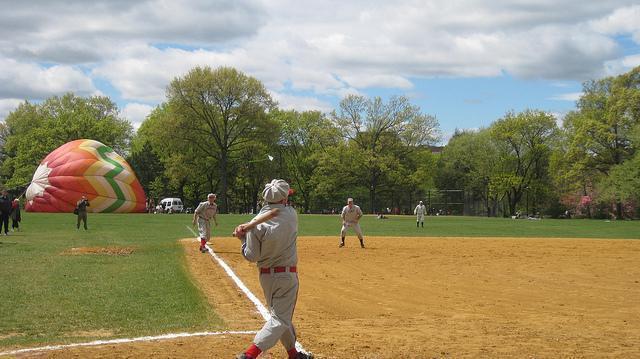What type of transport is visible here?
Pick the correct solution from the four options below to address the question.
Options: Car, plane, hotair balloon, bike. Hotair balloon. 